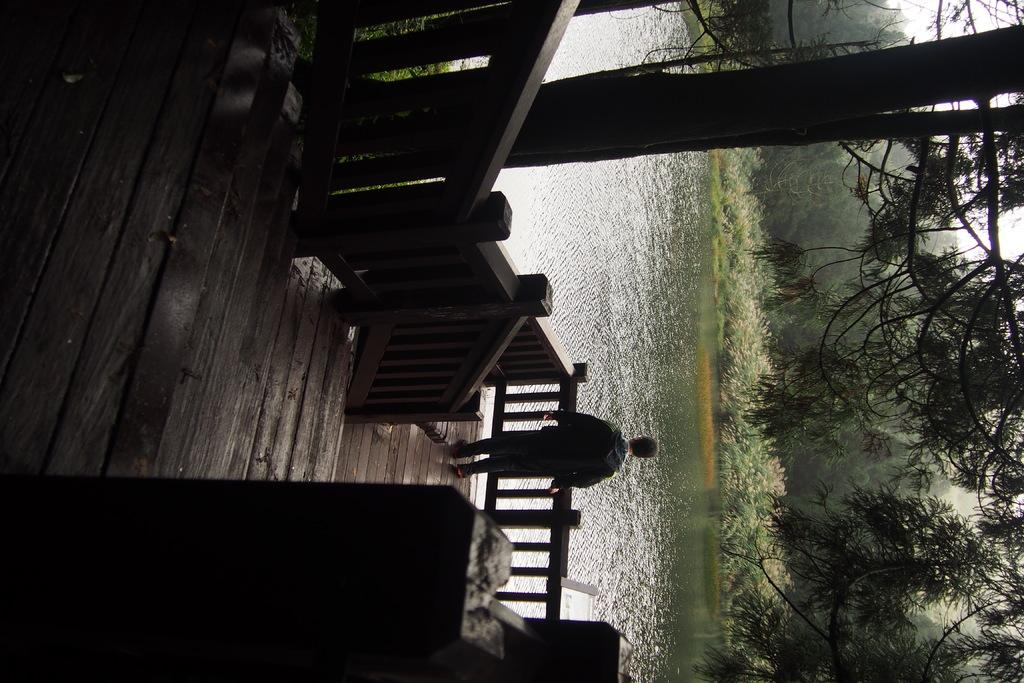What is the person in the image standing on? The person is standing on a wooden surface. What is located near the person in the image? The person is beside a fence. What type of natural environment can be seen in the image? There are trees and water visible in the image. What type of treatment is the person receiving in the image? There is no indication in the image that the person is receiving any treatment. 